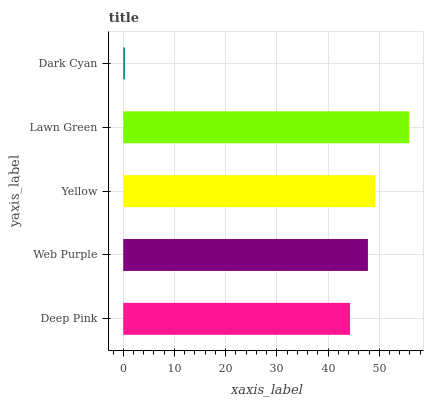Is Dark Cyan the minimum?
Answer yes or no. Yes. Is Lawn Green the maximum?
Answer yes or no. Yes. Is Web Purple the minimum?
Answer yes or no. No. Is Web Purple the maximum?
Answer yes or no. No. Is Web Purple greater than Deep Pink?
Answer yes or no. Yes. Is Deep Pink less than Web Purple?
Answer yes or no. Yes. Is Deep Pink greater than Web Purple?
Answer yes or no. No. Is Web Purple less than Deep Pink?
Answer yes or no. No. Is Web Purple the high median?
Answer yes or no. Yes. Is Web Purple the low median?
Answer yes or no. Yes. Is Dark Cyan the high median?
Answer yes or no. No. Is Deep Pink the low median?
Answer yes or no. No. 